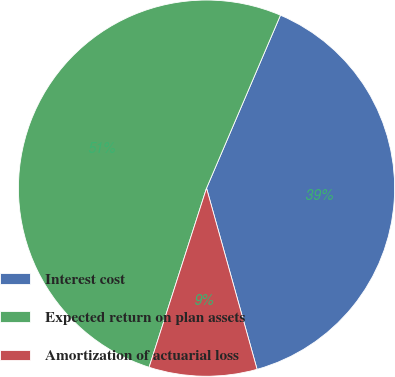Convert chart. <chart><loc_0><loc_0><loc_500><loc_500><pie_chart><fcel>Interest cost<fcel>Expected return on plan assets<fcel>Amortization of actuarial loss<nl><fcel>39.24%<fcel>51.49%<fcel>9.27%<nl></chart> 